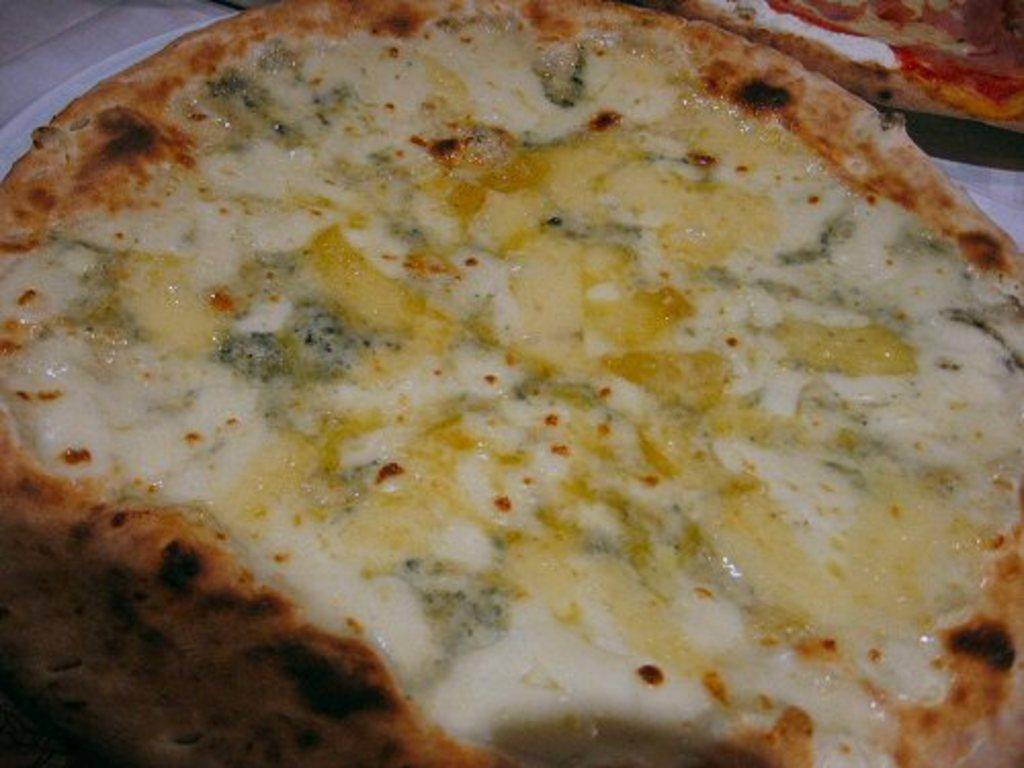How many pizzas are present in the image? There are two pizzas in the image. What can be seen on the surface of the pizzas? There are ingredients visible on the pizzas. Can you help the bit of cheese on the pizza reach the top of the image? There is no bit of cheese or any other specific ingredient mentioned in the image, so we cannot help it reach the top. 